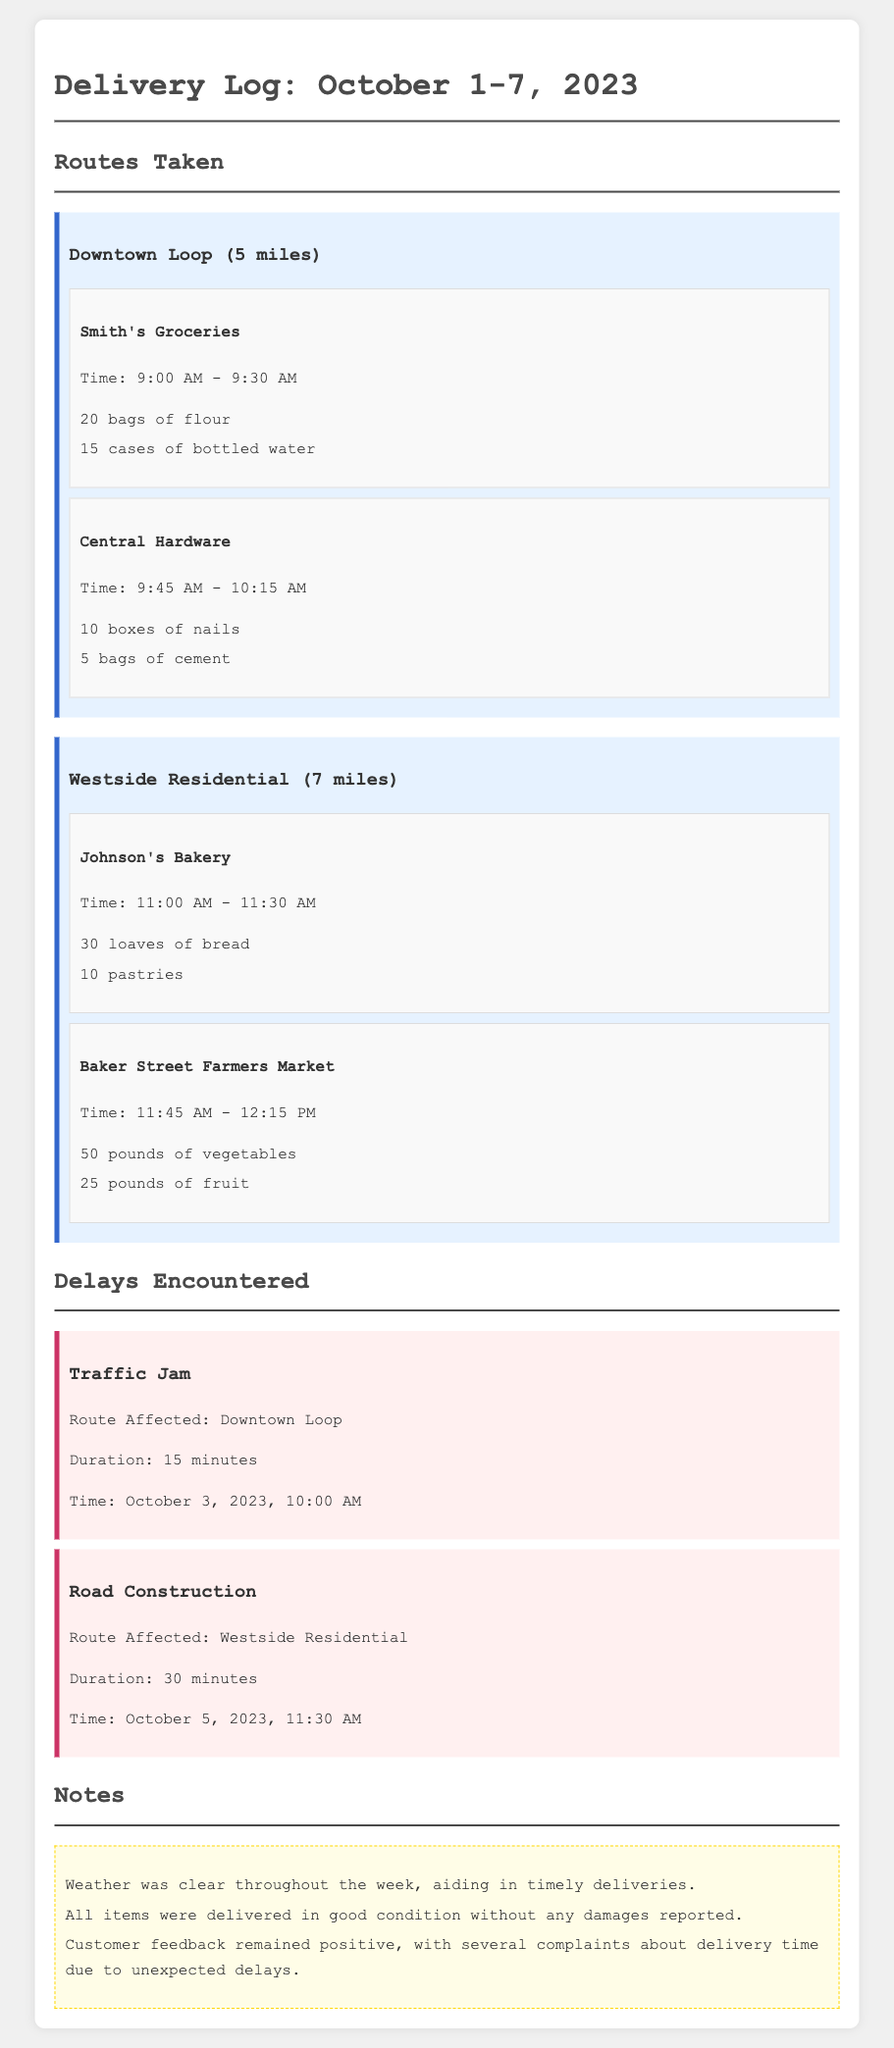What time did the delivery to Smith's Groceries occur? The delivery to Smith's Groceries took place from 9:00 AM to 9:30 AM.
Answer: 9:00 AM - 9:30 AM How many loaves of bread were delivered to Johnson's Bakery? The log indicates that 30 loaves of bread were delivered to Johnson's Bakery.
Answer: 30 loaves What was the duration of the traffic jam encountered? The traffic jam lasted for 15 minutes according to the delays section of the log.
Answer: 15 minutes Which route experienced road construction delays? The delay section indicates that the Westside Residential route was affected by road construction.
Answer: Westside Residential How many total stops were there in the Downtown Loop route? There were two stops listed under the Downtown Loop route: Smith's Groceries and Central Hardware.
Answer: 2 stops 